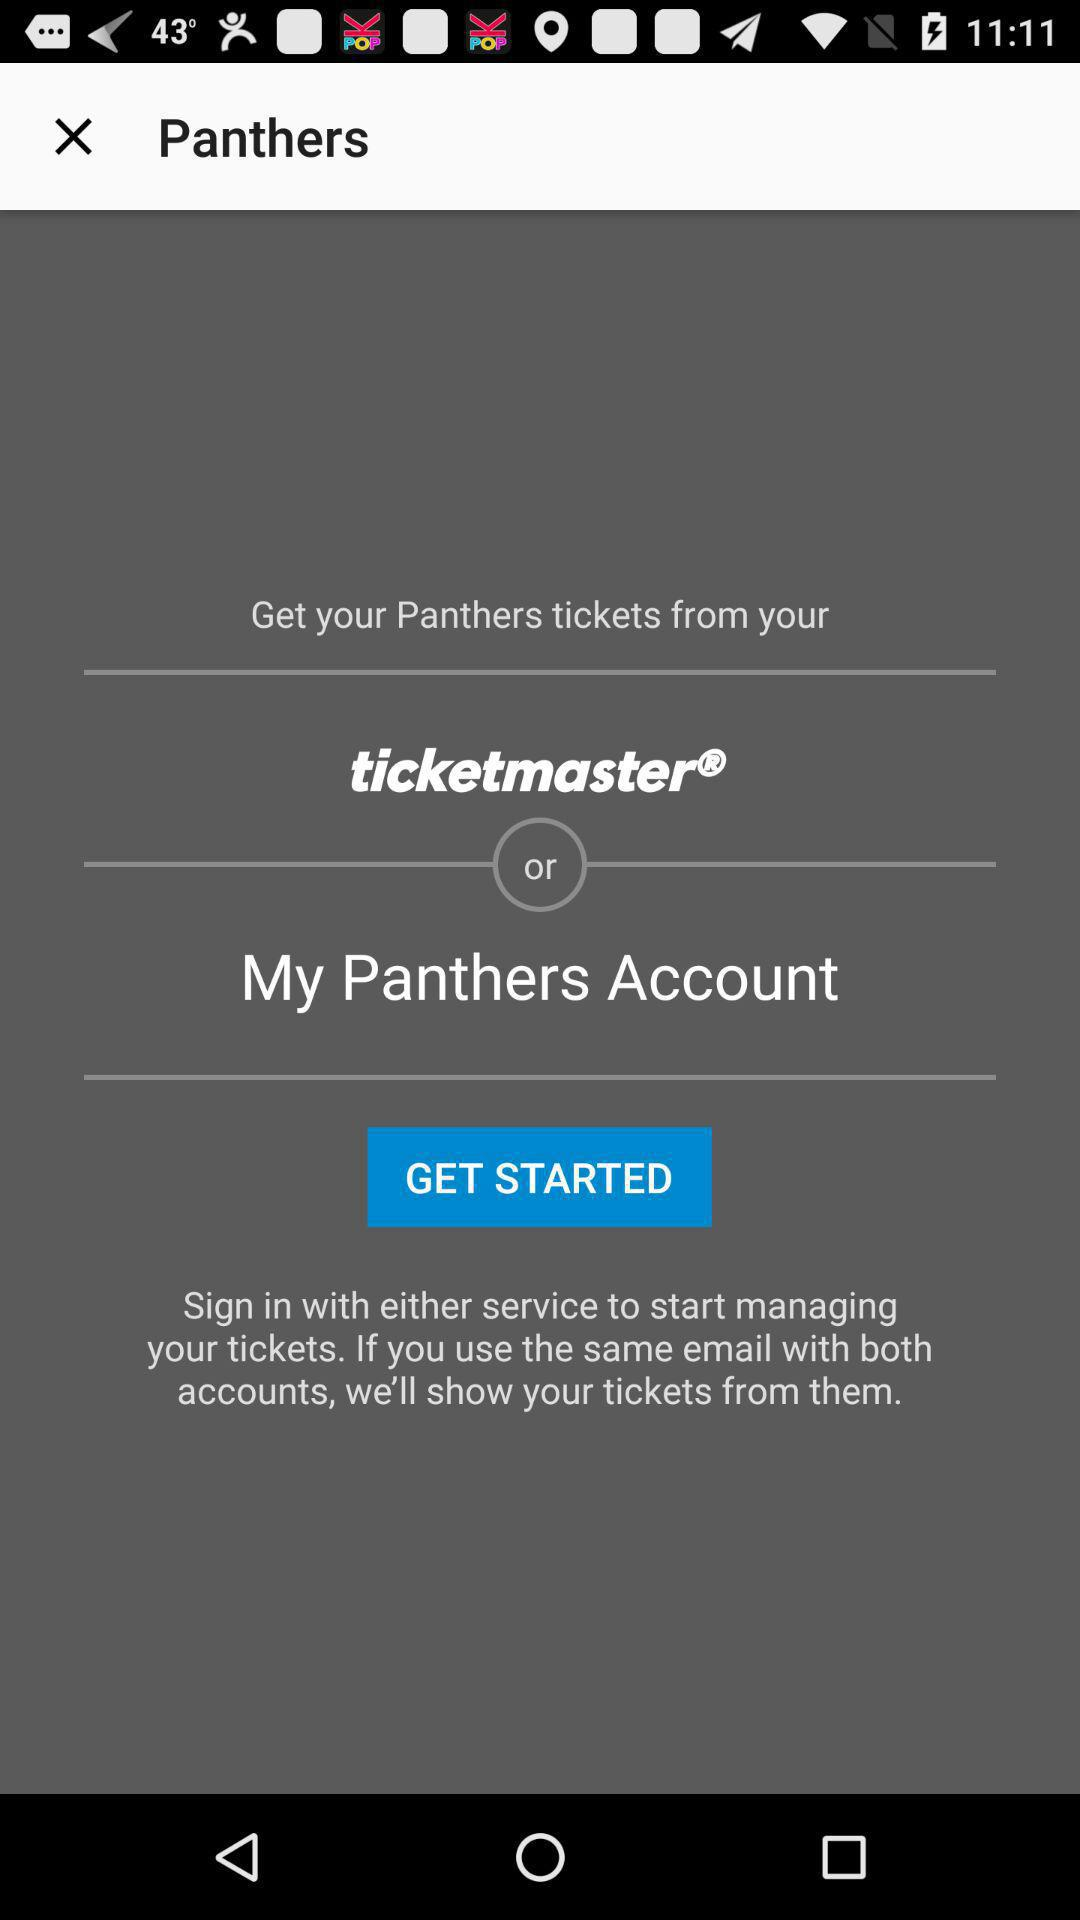What is the name of the application? The names of the applications are "Panthers" and "ticketmaster". 